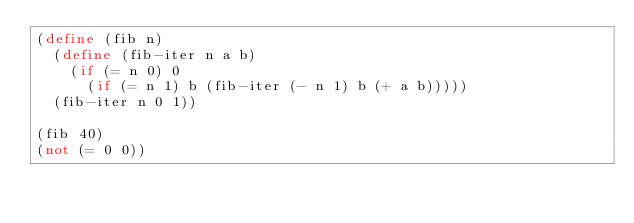<code> <loc_0><loc_0><loc_500><loc_500><_Scheme_>(define (fib n)
  (define (fib-iter n a b)
    (if (= n 0) 0
      (if (= n 1) b (fib-iter (- n 1) b (+ a b)))))
  (fib-iter n 0 1))

(fib 40)
(not (= 0 0))
</code> 